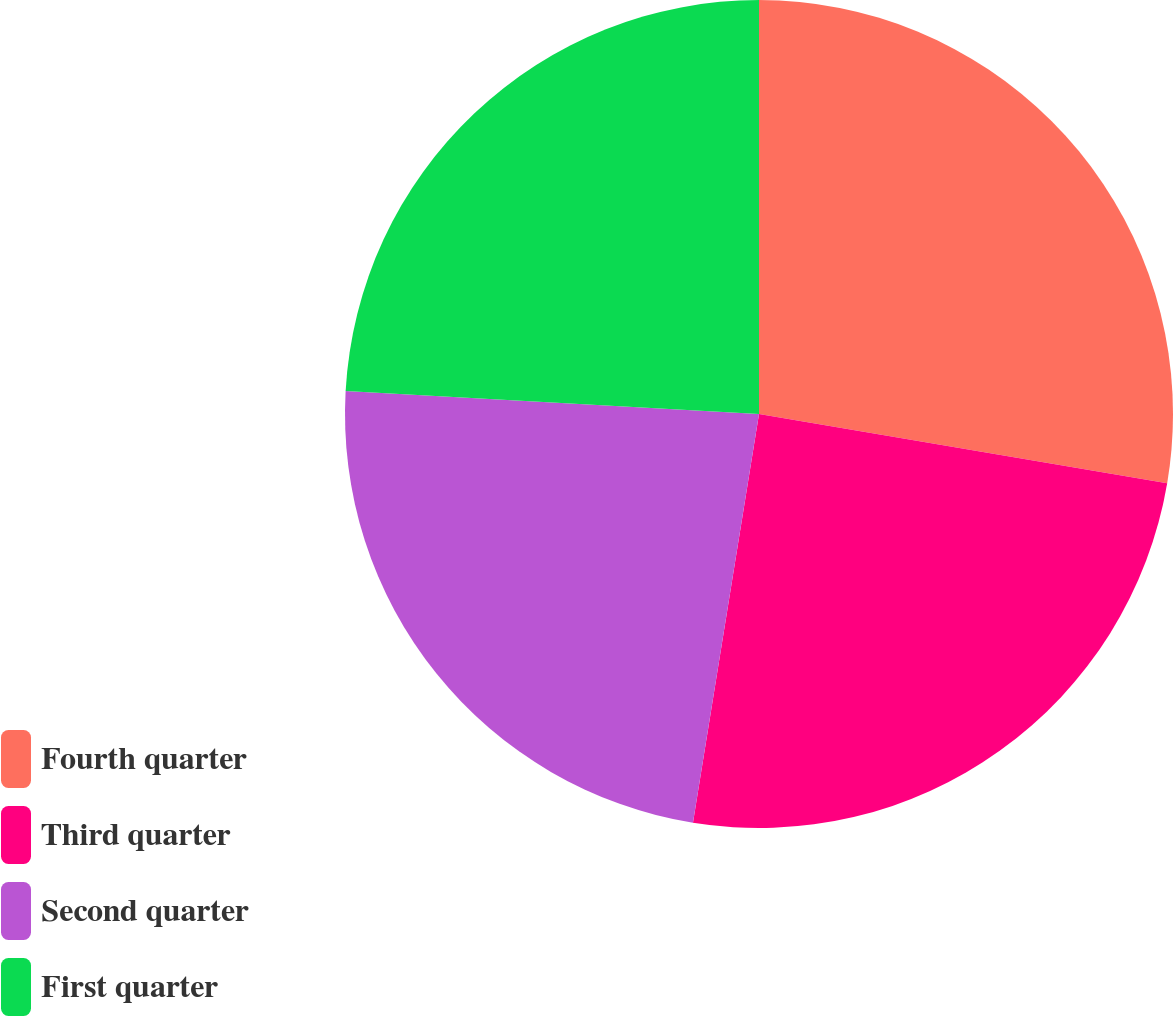<chart> <loc_0><loc_0><loc_500><loc_500><pie_chart><fcel>Fourth quarter<fcel>Third quarter<fcel>Second quarter<fcel>First quarter<nl><fcel>27.67%<fcel>24.88%<fcel>23.33%<fcel>24.12%<nl></chart> 